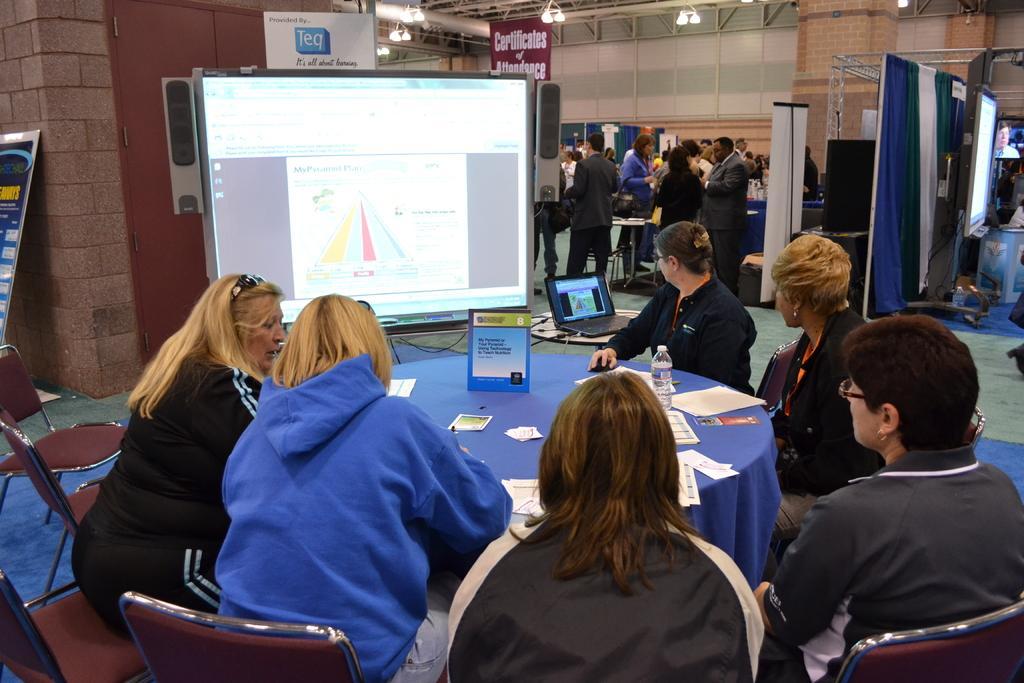Please provide a concise description of this image. In this image we can see some people sitting on the chairs beside the table containing a board, papers and a bottle. We can also see a projector, wall, door, a laptop and the floor. On the backside we can see some people standing. We can also see ceiling lights and a curtain. 